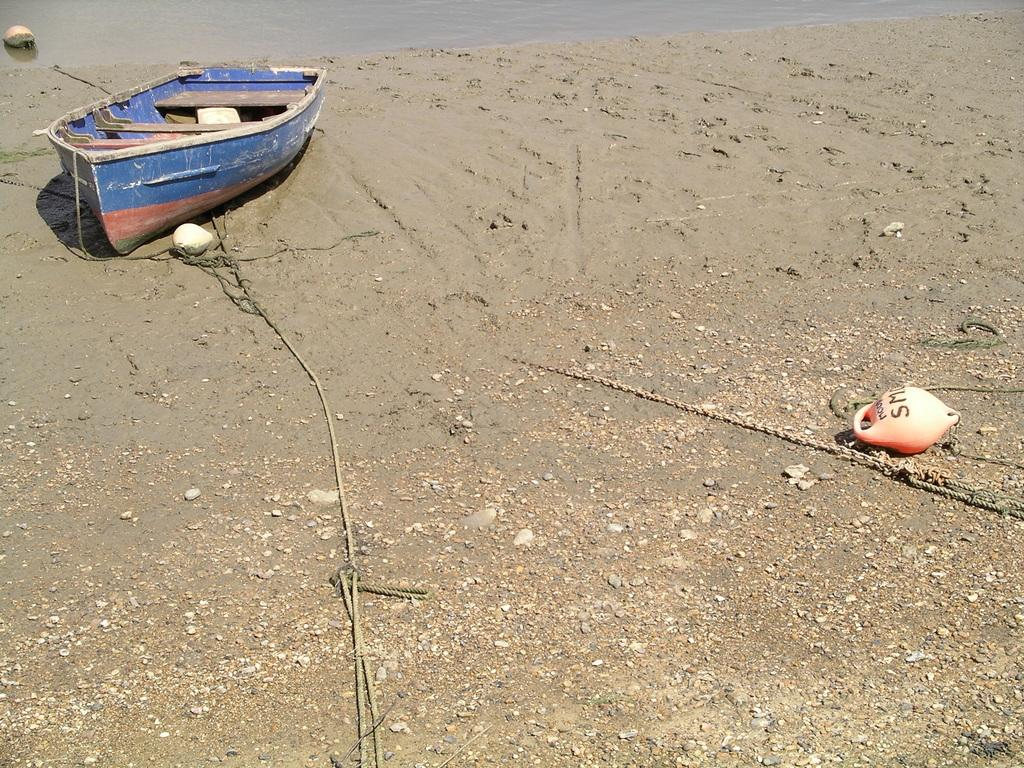<image>
Write a terse but informative summary of the picture. A small buoy is on the sand attached to a boat with Sm written int 